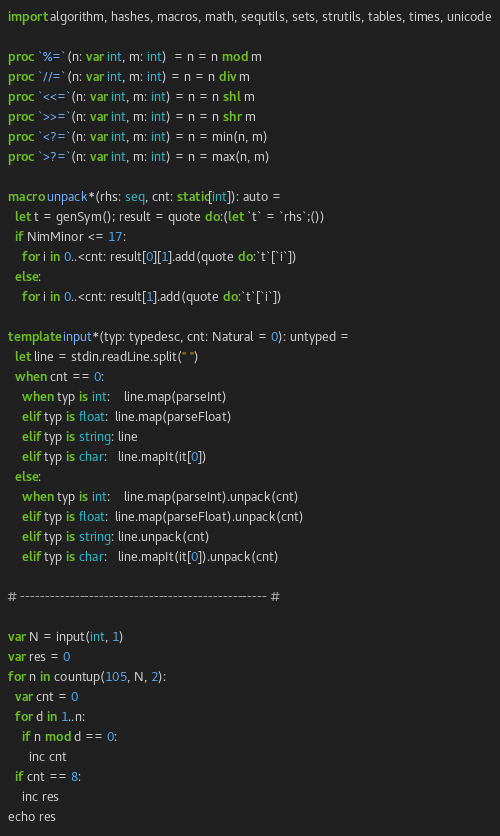Convert code to text. <code><loc_0><loc_0><loc_500><loc_500><_Nim_>import algorithm, hashes, macros, math, sequtils, sets, strutils, tables, times, unicode

proc `%=`(n: var int, m: int)  = n = n mod m
proc `//=`(n: var int, m: int) = n = n div m
proc `<<=`(n: var int, m: int) = n = n shl m
proc `>>=`(n: var int, m: int) = n = n shr m
proc `<?=`(n: var int, m: int) = n = min(n, m)
proc `>?=`(n: var int, m: int) = n = max(n, m)

macro unpack*(rhs: seq, cnt: static[int]): auto =
  let t = genSym(); result = quote do:(let `t` = `rhs`;())
  if NimMinor <= 17:
    for i in 0..<cnt: result[0][1].add(quote do:`t`[`i`])
  else:
    for i in 0..<cnt: result[1].add(quote do:`t`[`i`])

template input*(typ: typedesc, cnt: Natural = 0): untyped =
  let line = stdin.readLine.split(" ")
  when cnt == 0:
    when typ is int:    line.map(parseInt)
    elif typ is float:  line.map(parseFloat)
    elif typ is string: line
    elif typ is char:   line.mapIt(it[0])
  else:
    when typ is int:    line.map(parseInt).unpack(cnt)
    elif typ is float:  line.map(parseFloat).unpack(cnt)
    elif typ is string: line.unpack(cnt)
    elif typ is char:   line.mapIt(it[0]).unpack(cnt)

# -------------------------------------------------- #

var N = input(int, 1)
var res = 0
for n in countup(105, N, 2):
  var cnt = 0
  for d in 1..n:
    if n mod d == 0:
      inc cnt
  if cnt == 8:
    inc res
echo res</code> 